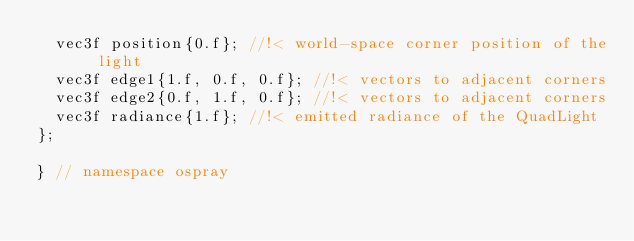Convert code to text. <code><loc_0><loc_0><loc_500><loc_500><_C_>  vec3f position{0.f}; //!< world-space corner position of the light
  vec3f edge1{1.f, 0.f, 0.f}; //!< vectors to adjacent corners
  vec3f edge2{0.f, 1.f, 0.f}; //!< vectors to adjacent corners
  vec3f radiance{1.f}; //!< emitted radiance of the QuadLight
};

} // namespace ospray
</code> 